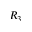Convert formula to latex. <formula><loc_0><loc_0><loc_500><loc_500>R _ { 3 }</formula> 